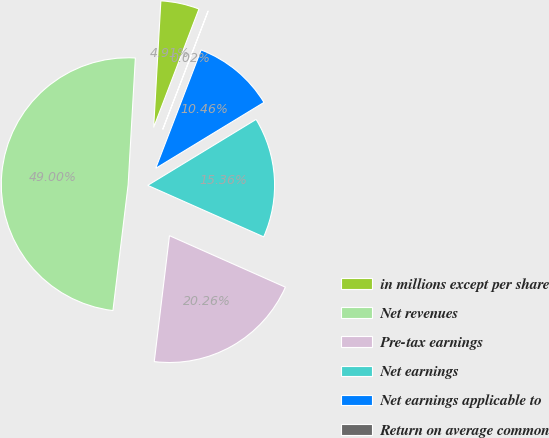<chart> <loc_0><loc_0><loc_500><loc_500><pie_chart><fcel>in millions except per share<fcel>Net revenues<fcel>Pre-tax earnings<fcel>Net earnings<fcel>Net earnings applicable to<fcel>Return on average common<nl><fcel>4.91%<fcel>49.0%<fcel>20.26%<fcel>15.36%<fcel>10.46%<fcel>0.02%<nl></chart> 